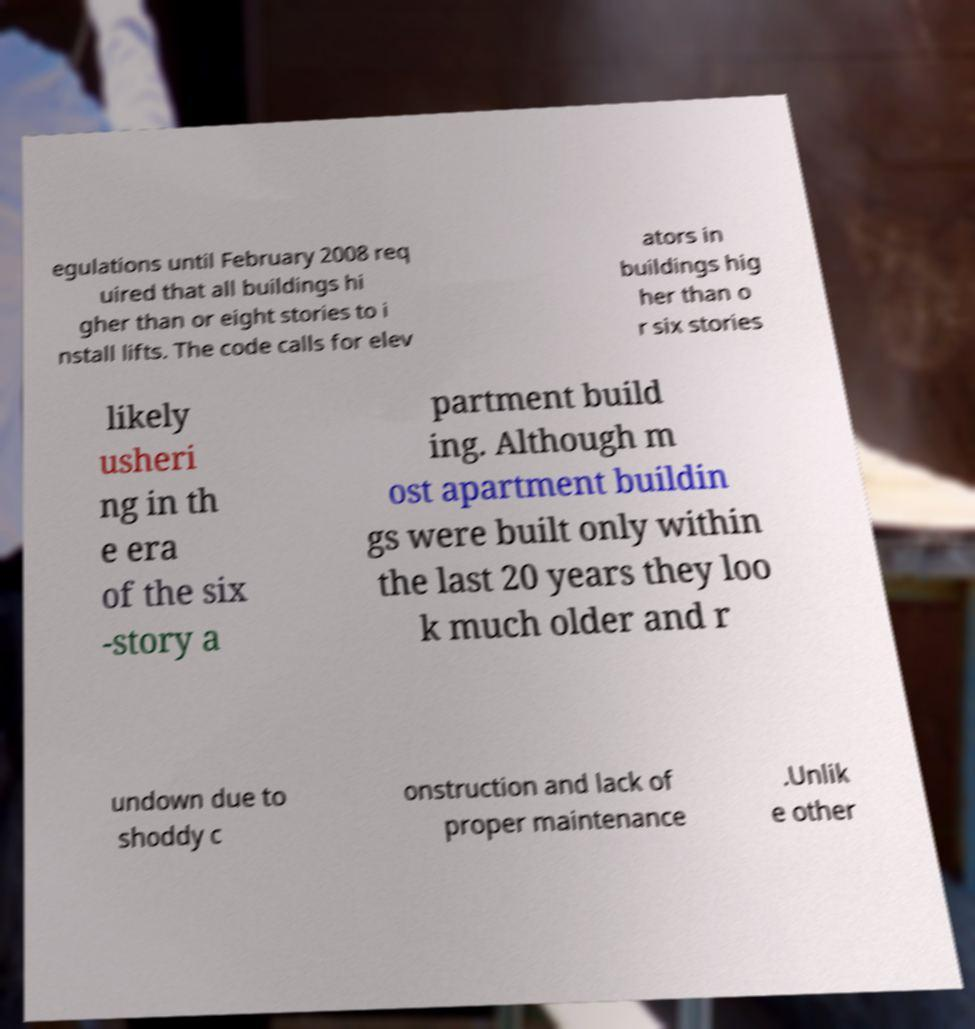Please identify and transcribe the text found in this image. egulations until February 2008 req uired that all buildings hi gher than or eight stories to i nstall lifts. The code calls for elev ators in buildings hig her than o r six stories likely usheri ng in th e era of the six -story a partment build ing. Although m ost apartment buildin gs were built only within the last 20 years they loo k much older and r undown due to shoddy c onstruction and lack of proper maintenance .Unlik e other 